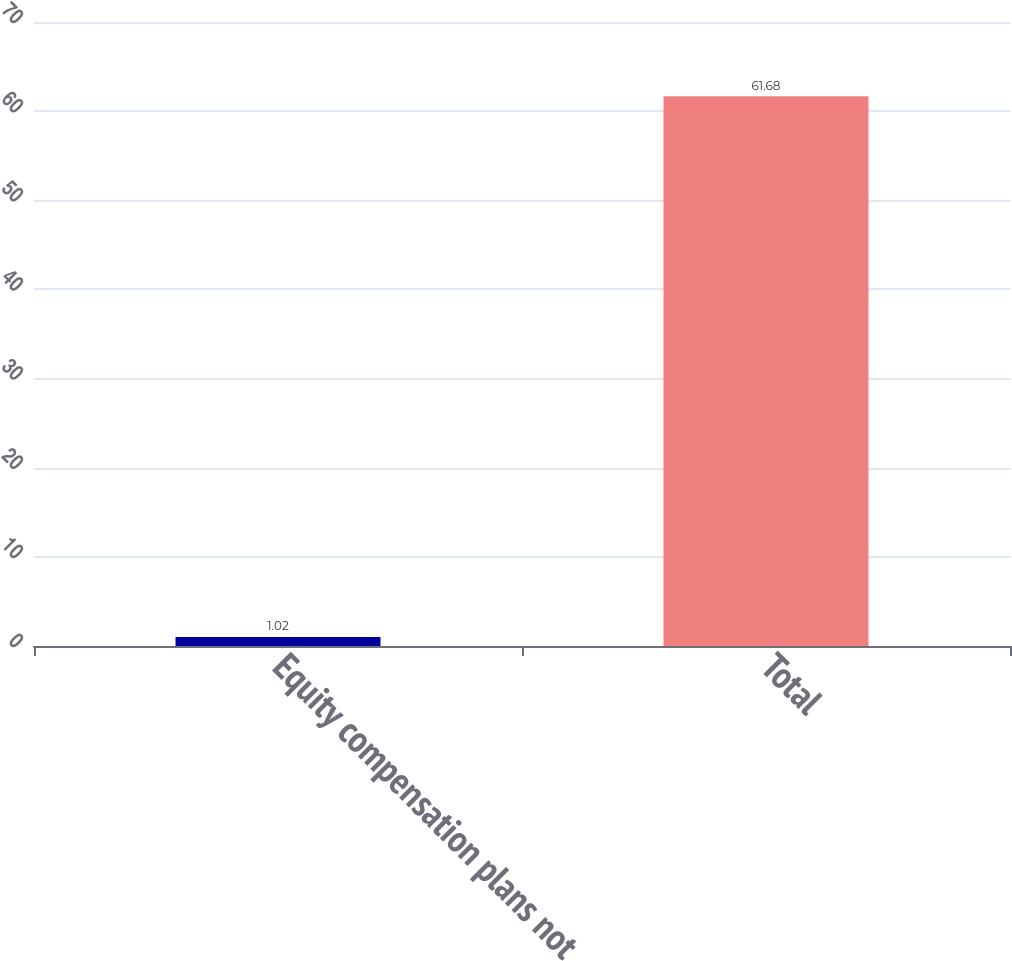<chart> <loc_0><loc_0><loc_500><loc_500><bar_chart><fcel>Equity compensation plans not<fcel>Total<nl><fcel>1.02<fcel>61.68<nl></chart> 